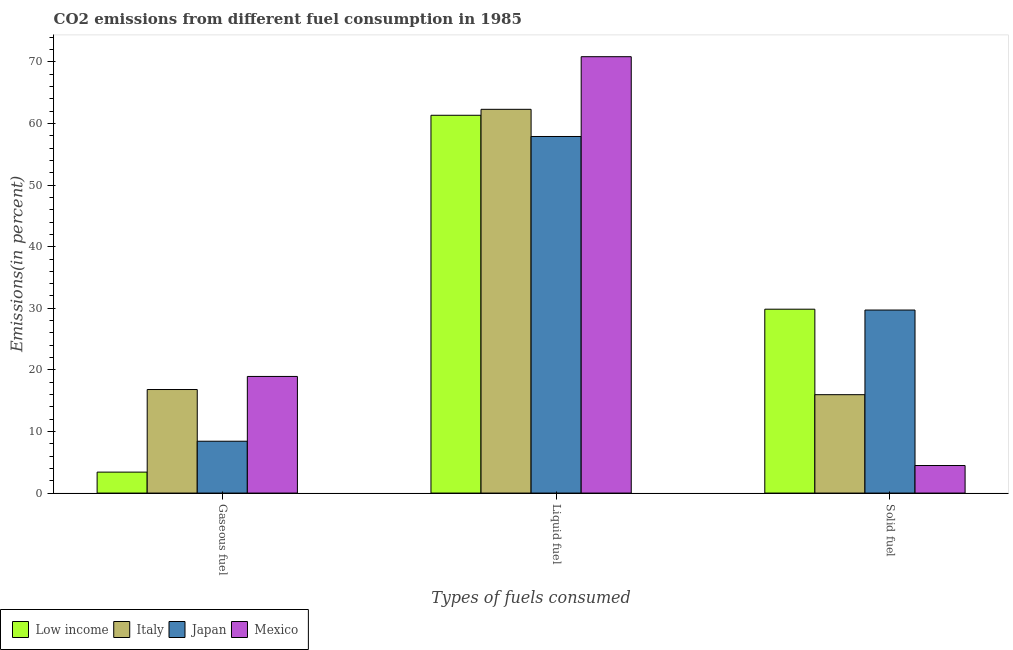How many groups of bars are there?
Make the answer very short. 3. Are the number of bars per tick equal to the number of legend labels?
Your answer should be compact. Yes. How many bars are there on the 3rd tick from the right?
Offer a very short reply. 4. What is the label of the 3rd group of bars from the left?
Your response must be concise. Solid fuel. What is the percentage of solid fuel emission in Low income?
Offer a very short reply. 29.85. Across all countries, what is the maximum percentage of gaseous fuel emission?
Provide a short and direct response. 18.93. Across all countries, what is the minimum percentage of solid fuel emission?
Give a very brief answer. 4.47. In which country was the percentage of gaseous fuel emission maximum?
Provide a short and direct response. Mexico. What is the total percentage of liquid fuel emission in the graph?
Give a very brief answer. 252.37. What is the difference between the percentage of solid fuel emission in Mexico and that in Japan?
Your response must be concise. -25.24. What is the difference between the percentage of gaseous fuel emission in Japan and the percentage of liquid fuel emission in Mexico?
Provide a short and direct response. -62.43. What is the average percentage of solid fuel emission per country?
Offer a very short reply. 20. What is the difference between the percentage of liquid fuel emission and percentage of solid fuel emission in Japan?
Your response must be concise. 28.17. What is the ratio of the percentage of solid fuel emission in Italy to that in Low income?
Offer a terse response. 0.54. Is the percentage of gaseous fuel emission in Japan less than that in Italy?
Your response must be concise. Yes. What is the difference between the highest and the second highest percentage of liquid fuel emission?
Provide a short and direct response. 8.54. What is the difference between the highest and the lowest percentage of solid fuel emission?
Make the answer very short. 25.38. Is it the case that in every country, the sum of the percentage of gaseous fuel emission and percentage of liquid fuel emission is greater than the percentage of solid fuel emission?
Ensure brevity in your answer.  Yes. Are all the bars in the graph horizontal?
Your answer should be compact. No. How many countries are there in the graph?
Keep it short and to the point. 4. What is the difference between two consecutive major ticks on the Y-axis?
Provide a succinct answer. 10. Does the graph contain any zero values?
Offer a terse response. No. Does the graph contain grids?
Offer a very short reply. No. How many legend labels are there?
Offer a terse response. 4. How are the legend labels stacked?
Offer a very short reply. Horizontal. What is the title of the graph?
Make the answer very short. CO2 emissions from different fuel consumption in 1985. What is the label or title of the X-axis?
Provide a short and direct response. Types of fuels consumed. What is the label or title of the Y-axis?
Offer a very short reply. Emissions(in percent). What is the Emissions(in percent) in Low income in Gaseous fuel?
Offer a very short reply. 3.4. What is the Emissions(in percent) in Italy in Gaseous fuel?
Keep it short and to the point. 16.81. What is the Emissions(in percent) of Japan in Gaseous fuel?
Make the answer very short. 8.42. What is the Emissions(in percent) of Mexico in Gaseous fuel?
Make the answer very short. 18.93. What is the Emissions(in percent) of Low income in Liquid fuel?
Provide a short and direct response. 61.34. What is the Emissions(in percent) of Italy in Liquid fuel?
Offer a terse response. 62.3. What is the Emissions(in percent) in Japan in Liquid fuel?
Provide a succinct answer. 57.89. What is the Emissions(in percent) in Mexico in Liquid fuel?
Provide a succinct answer. 70.84. What is the Emissions(in percent) of Low income in Solid fuel?
Your answer should be very brief. 29.85. What is the Emissions(in percent) in Italy in Solid fuel?
Provide a short and direct response. 15.97. What is the Emissions(in percent) of Japan in Solid fuel?
Give a very brief answer. 29.72. What is the Emissions(in percent) in Mexico in Solid fuel?
Offer a terse response. 4.47. Across all Types of fuels consumed, what is the maximum Emissions(in percent) in Low income?
Offer a very short reply. 61.34. Across all Types of fuels consumed, what is the maximum Emissions(in percent) of Italy?
Ensure brevity in your answer.  62.3. Across all Types of fuels consumed, what is the maximum Emissions(in percent) in Japan?
Provide a succinct answer. 57.89. Across all Types of fuels consumed, what is the maximum Emissions(in percent) of Mexico?
Make the answer very short. 70.84. Across all Types of fuels consumed, what is the minimum Emissions(in percent) of Low income?
Provide a short and direct response. 3.4. Across all Types of fuels consumed, what is the minimum Emissions(in percent) of Italy?
Give a very brief answer. 15.97. Across all Types of fuels consumed, what is the minimum Emissions(in percent) of Japan?
Offer a terse response. 8.42. Across all Types of fuels consumed, what is the minimum Emissions(in percent) of Mexico?
Provide a short and direct response. 4.47. What is the total Emissions(in percent) of Low income in the graph?
Offer a very short reply. 94.59. What is the total Emissions(in percent) in Italy in the graph?
Offer a very short reply. 95.08. What is the total Emissions(in percent) in Japan in the graph?
Offer a very short reply. 96.02. What is the total Emissions(in percent) of Mexico in the graph?
Make the answer very short. 94.25. What is the difference between the Emissions(in percent) of Low income in Gaseous fuel and that in Liquid fuel?
Your answer should be very brief. -57.93. What is the difference between the Emissions(in percent) in Italy in Gaseous fuel and that in Liquid fuel?
Give a very brief answer. -45.49. What is the difference between the Emissions(in percent) of Japan in Gaseous fuel and that in Liquid fuel?
Your response must be concise. -49.47. What is the difference between the Emissions(in percent) in Mexico in Gaseous fuel and that in Liquid fuel?
Your response must be concise. -51.91. What is the difference between the Emissions(in percent) in Low income in Gaseous fuel and that in Solid fuel?
Offer a terse response. -26.45. What is the difference between the Emissions(in percent) of Italy in Gaseous fuel and that in Solid fuel?
Keep it short and to the point. 0.84. What is the difference between the Emissions(in percent) of Japan in Gaseous fuel and that in Solid fuel?
Offer a very short reply. -21.3. What is the difference between the Emissions(in percent) of Mexico in Gaseous fuel and that in Solid fuel?
Make the answer very short. 14.46. What is the difference between the Emissions(in percent) in Low income in Liquid fuel and that in Solid fuel?
Provide a succinct answer. 31.48. What is the difference between the Emissions(in percent) of Italy in Liquid fuel and that in Solid fuel?
Your answer should be very brief. 46.33. What is the difference between the Emissions(in percent) in Japan in Liquid fuel and that in Solid fuel?
Your answer should be very brief. 28.17. What is the difference between the Emissions(in percent) of Mexico in Liquid fuel and that in Solid fuel?
Offer a very short reply. 66.37. What is the difference between the Emissions(in percent) in Low income in Gaseous fuel and the Emissions(in percent) in Italy in Liquid fuel?
Your answer should be compact. -58.9. What is the difference between the Emissions(in percent) of Low income in Gaseous fuel and the Emissions(in percent) of Japan in Liquid fuel?
Your answer should be compact. -54.49. What is the difference between the Emissions(in percent) in Low income in Gaseous fuel and the Emissions(in percent) in Mexico in Liquid fuel?
Make the answer very short. -67.44. What is the difference between the Emissions(in percent) in Italy in Gaseous fuel and the Emissions(in percent) in Japan in Liquid fuel?
Provide a succinct answer. -41.08. What is the difference between the Emissions(in percent) in Italy in Gaseous fuel and the Emissions(in percent) in Mexico in Liquid fuel?
Give a very brief answer. -54.03. What is the difference between the Emissions(in percent) in Japan in Gaseous fuel and the Emissions(in percent) in Mexico in Liquid fuel?
Offer a very short reply. -62.43. What is the difference between the Emissions(in percent) in Low income in Gaseous fuel and the Emissions(in percent) in Italy in Solid fuel?
Your answer should be very brief. -12.57. What is the difference between the Emissions(in percent) in Low income in Gaseous fuel and the Emissions(in percent) in Japan in Solid fuel?
Provide a short and direct response. -26.31. What is the difference between the Emissions(in percent) in Low income in Gaseous fuel and the Emissions(in percent) in Mexico in Solid fuel?
Give a very brief answer. -1.07. What is the difference between the Emissions(in percent) in Italy in Gaseous fuel and the Emissions(in percent) in Japan in Solid fuel?
Your response must be concise. -12.91. What is the difference between the Emissions(in percent) in Italy in Gaseous fuel and the Emissions(in percent) in Mexico in Solid fuel?
Your answer should be very brief. 12.34. What is the difference between the Emissions(in percent) of Japan in Gaseous fuel and the Emissions(in percent) of Mexico in Solid fuel?
Give a very brief answer. 3.94. What is the difference between the Emissions(in percent) of Low income in Liquid fuel and the Emissions(in percent) of Italy in Solid fuel?
Provide a short and direct response. 45.36. What is the difference between the Emissions(in percent) of Low income in Liquid fuel and the Emissions(in percent) of Japan in Solid fuel?
Your answer should be compact. 31.62. What is the difference between the Emissions(in percent) in Low income in Liquid fuel and the Emissions(in percent) in Mexico in Solid fuel?
Offer a terse response. 56.86. What is the difference between the Emissions(in percent) of Italy in Liquid fuel and the Emissions(in percent) of Japan in Solid fuel?
Provide a short and direct response. 32.59. What is the difference between the Emissions(in percent) of Italy in Liquid fuel and the Emissions(in percent) of Mexico in Solid fuel?
Offer a very short reply. 57.83. What is the difference between the Emissions(in percent) of Japan in Liquid fuel and the Emissions(in percent) of Mexico in Solid fuel?
Provide a short and direct response. 53.42. What is the average Emissions(in percent) in Low income per Types of fuels consumed?
Keep it short and to the point. 31.53. What is the average Emissions(in percent) of Italy per Types of fuels consumed?
Your answer should be compact. 31.69. What is the average Emissions(in percent) in Japan per Types of fuels consumed?
Offer a terse response. 32.01. What is the average Emissions(in percent) of Mexico per Types of fuels consumed?
Your answer should be very brief. 31.42. What is the difference between the Emissions(in percent) in Low income and Emissions(in percent) in Italy in Gaseous fuel?
Your response must be concise. -13.41. What is the difference between the Emissions(in percent) in Low income and Emissions(in percent) in Japan in Gaseous fuel?
Offer a terse response. -5.01. What is the difference between the Emissions(in percent) of Low income and Emissions(in percent) of Mexico in Gaseous fuel?
Offer a terse response. -15.53. What is the difference between the Emissions(in percent) of Italy and Emissions(in percent) of Japan in Gaseous fuel?
Make the answer very short. 8.39. What is the difference between the Emissions(in percent) of Italy and Emissions(in percent) of Mexico in Gaseous fuel?
Offer a very short reply. -2.12. What is the difference between the Emissions(in percent) in Japan and Emissions(in percent) in Mexico in Gaseous fuel?
Your answer should be compact. -10.52. What is the difference between the Emissions(in percent) of Low income and Emissions(in percent) of Italy in Liquid fuel?
Offer a terse response. -0.97. What is the difference between the Emissions(in percent) of Low income and Emissions(in percent) of Japan in Liquid fuel?
Ensure brevity in your answer.  3.45. What is the difference between the Emissions(in percent) in Low income and Emissions(in percent) in Mexico in Liquid fuel?
Keep it short and to the point. -9.51. What is the difference between the Emissions(in percent) in Italy and Emissions(in percent) in Japan in Liquid fuel?
Your response must be concise. 4.41. What is the difference between the Emissions(in percent) of Italy and Emissions(in percent) of Mexico in Liquid fuel?
Make the answer very short. -8.54. What is the difference between the Emissions(in percent) in Japan and Emissions(in percent) in Mexico in Liquid fuel?
Make the answer very short. -12.96. What is the difference between the Emissions(in percent) in Low income and Emissions(in percent) in Italy in Solid fuel?
Keep it short and to the point. 13.88. What is the difference between the Emissions(in percent) in Low income and Emissions(in percent) in Japan in Solid fuel?
Your answer should be compact. 0.14. What is the difference between the Emissions(in percent) of Low income and Emissions(in percent) of Mexico in Solid fuel?
Your response must be concise. 25.38. What is the difference between the Emissions(in percent) in Italy and Emissions(in percent) in Japan in Solid fuel?
Your answer should be compact. -13.74. What is the difference between the Emissions(in percent) in Italy and Emissions(in percent) in Mexico in Solid fuel?
Offer a terse response. 11.5. What is the difference between the Emissions(in percent) in Japan and Emissions(in percent) in Mexico in Solid fuel?
Offer a very short reply. 25.24. What is the ratio of the Emissions(in percent) in Low income in Gaseous fuel to that in Liquid fuel?
Give a very brief answer. 0.06. What is the ratio of the Emissions(in percent) in Italy in Gaseous fuel to that in Liquid fuel?
Your response must be concise. 0.27. What is the ratio of the Emissions(in percent) of Japan in Gaseous fuel to that in Liquid fuel?
Your answer should be very brief. 0.15. What is the ratio of the Emissions(in percent) of Mexico in Gaseous fuel to that in Liquid fuel?
Keep it short and to the point. 0.27. What is the ratio of the Emissions(in percent) in Low income in Gaseous fuel to that in Solid fuel?
Offer a very short reply. 0.11. What is the ratio of the Emissions(in percent) of Italy in Gaseous fuel to that in Solid fuel?
Provide a short and direct response. 1.05. What is the ratio of the Emissions(in percent) in Japan in Gaseous fuel to that in Solid fuel?
Offer a very short reply. 0.28. What is the ratio of the Emissions(in percent) of Mexico in Gaseous fuel to that in Solid fuel?
Ensure brevity in your answer.  4.23. What is the ratio of the Emissions(in percent) of Low income in Liquid fuel to that in Solid fuel?
Your answer should be compact. 2.05. What is the ratio of the Emissions(in percent) in Italy in Liquid fuel to that in Solid fuel?
Your response must be concise. 3.9. What is the ratio of the Emissions(in percent) in Japan in Liquid fuel to that in Solid fuel?
Offer a very short reply. 1.95. What is the ratio of the Emissions(in percent) in Mexico in Liquid fuel to that in Solid fuel?
Your answer should be compact. 15.84. What is the difference between the highest and the second highest Emissions(in percent) of Low income?
Ensure brevity in your answer.  31.48. What is the difference between the highest and the second highest Emissions(in percent) in Italy?
Keep it short and to the point. 45.49. What is the difference between the highest and the second highest Emissions(in percent) in Japan?
Ensure brevity in your answer.  28.17. What is the difference between the highest and the second highest Emissions(in percent) of Mexico?
Offer a very short reply. 51.91. What is the difference between the highest and the lowest Emissions(in percent) in Low income?
Provide a short and direct response. 57.93. What is the difference between the highest and the lowest Emissions(in percent) in Italy?
Your response must be concise. 46.33. What is the difference between the highest and the lowest Emissions(in percent) of Japan?
Offer a terse response. 49.47. What is the difference between the highest and the lowest Emissions(in percent) in Mexico?
Make the answer very short. 66.37. 